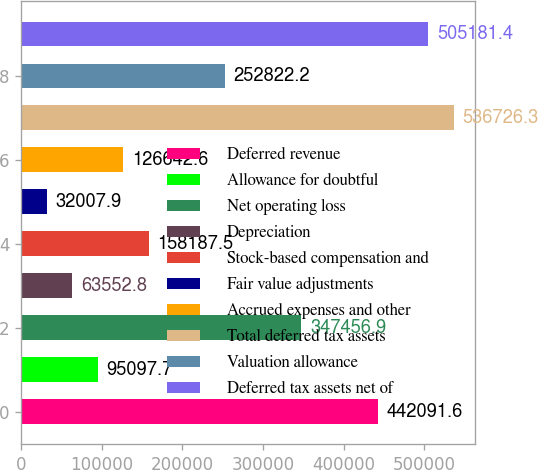<chart> <loc_0><loc_0><loc_500><loc_500><bar_chart><fcel>Deferred revenue<fcel>Allowance for doubtful<fcel>Net operating loss<fcel>Depreciation<fcel>Stock-based compensation and<fcel>Fair value adjustments<fcel>Accrued expenses and other<fcel>Total deferred tax assets<fcel>Valuation allowance<fcel>Deferred tax assets net of<nl><fcel>442092<fcel>95097.7<fcel>347457<fcel>63552.8<fcel>158188<fcel>32007.9<fcel>126643<fcel>536726<fcel>252822<fcel>505181<nl></chart> 